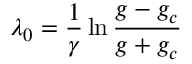<formula> <loc_0><loc_0><loc_500><loc_500>\lambda _ { 0 } = \frac { 1 } { \gamma } \ln \frac { g - g _ { c } } { g + g _ { c } }</formula> 